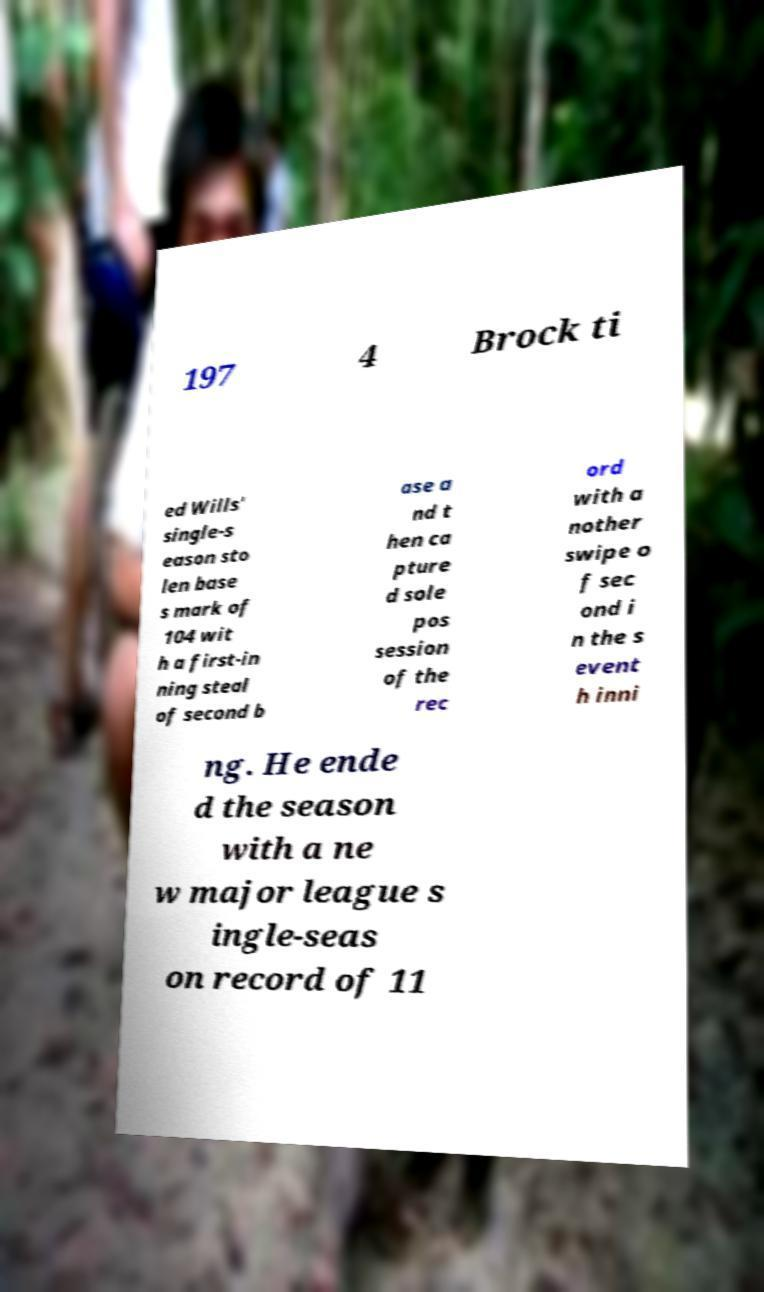Could you extract and type out the text from this image? 197 4 Brock ti ed Wills' single-s eason sto len base s mark of 104 wit h a first-in ning steal of second b ase a nd t hen ca pture d sole pos session of the rec ord with a nother swipe o f sec ond i n the s event h inni ng. He ende d the season with a ne w major league s ingle-seas on record of 11 